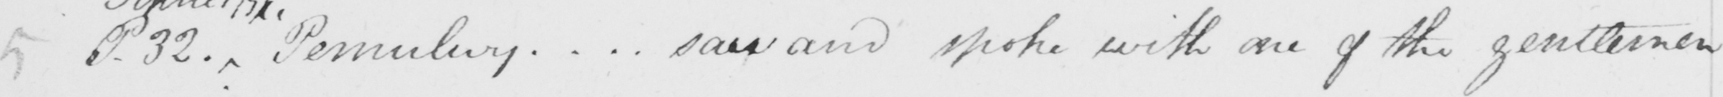Can you tell me what this handwritten text says? P.32 -  . Pemulwuy .. . saw and spoke with one of the gentlemen 